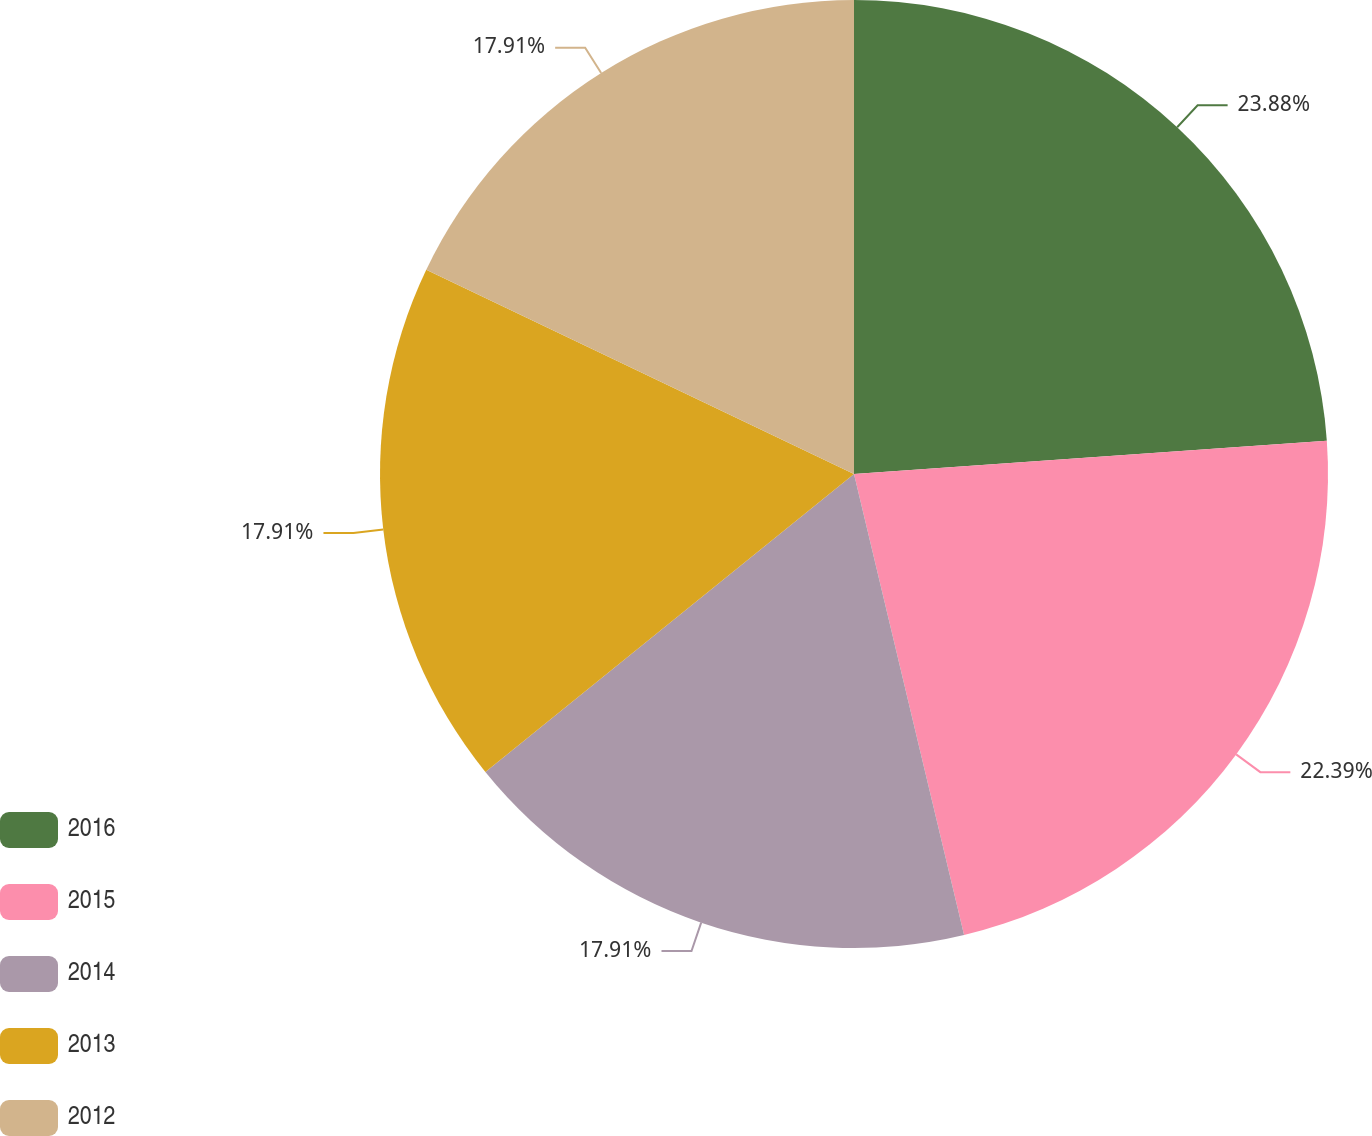Convert chart to OTSL. <chart><loc_0><loc_0><loc_500><loc_500><pie_chart><fcel>2016<fcel>2015<fcel>2014<fcel>2013<fcel>2012<nl><fcel>23.88%<fcel>22.39%<fcel>17.91%<fcel>17.91%<fcel>17.91%<nl></chart> 